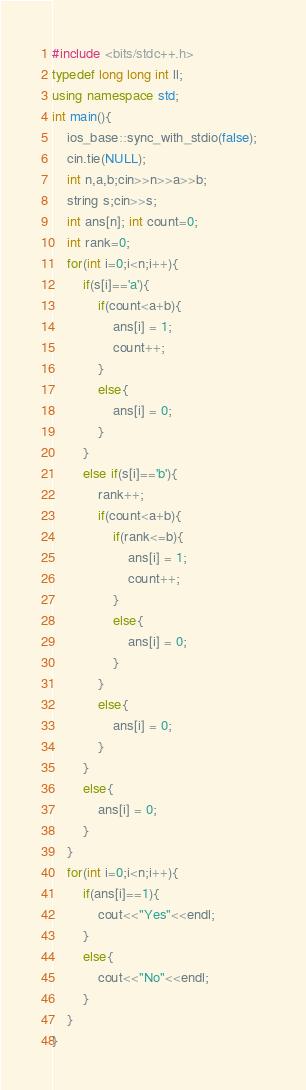Convert code to text. <code><loc_0><loc_0><loc_500><loc_500><_C++_>#include <bits/stdc++.h>
typedef long long int ll;
using namespace std;
int main(){
	ios_base::sync_with_stdio(false);  
	cin.tie(NULL);
	int n,a,b;cin>>n>>a>>b;
	string s;cin>>s;
	int ans[n]; int count=0;
	int rank=0;
	for(int i=0;i<n;i++){
		if(s[i]=='a'){
			if(count<a+b){
				ans[i] = 1;
				count++;
			}
			else{
				ans[i] = 0;
			}
		}
		else if(s[i]=='b'){
			rank++;
			if(count<a+b){
				if(rank<=b){
					ans[i] = 1;
					count++;
				}
				else{
					ans[i] = 0;
				}
			}
			else{
				ans[i] = 0;
			}
		}
		else{
			ans[i] = 0;
		}
	}
	for(int i=0;i<n;i++){
		if(ans[i]==1){
			cout<<"Yes"<<endl;
		}
		else{
			cout<<"No"<<endl;
		}
	}
}</code> 